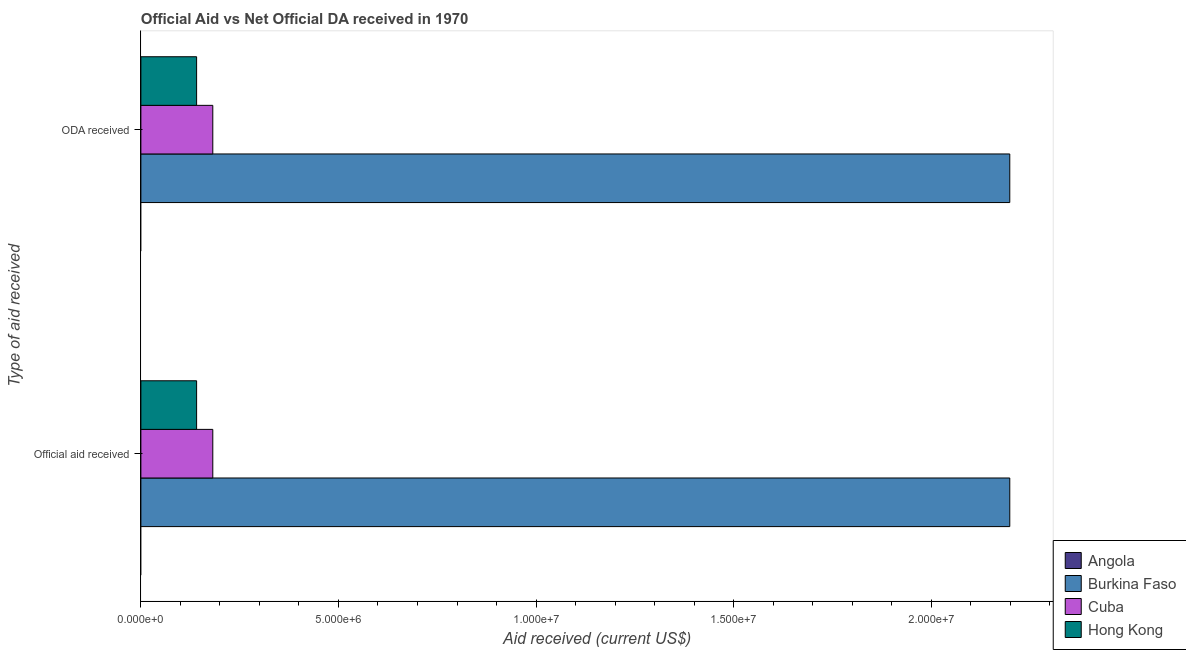How many groups of bars are there?
Ensure brevity in your answer.  2. Are the number of bars on each tick of the Y-axis equal?
Your answer should be very brief. Yes. How many bars are there on the 2nd tick from the bottom?
Make the answer very short. 3. What is the label of the 1st group of bars from the top?
Offer a very short reply. ODA received. What is the official aid received in Angola?
Your answer should be very brief. 0. Across all countries, what is the maximum oda received?
Offer a terse response. 2.20e+07. In which country was the official aid received maximum?
Ensure brevity in your answer.  Burkina Faso. What is the total oda received in the graph?
Your answer should be very brief. 2.52e+07. What is the difference between the oda received in Cuba and that in Burkina Faso?
Offer a very short reply. -2.02e+07. What is the difference between the oda received in Burkina Faso and the official aid received in Cuba?
Keep it short and to the point. 2.02e+07. What is the average official aid received per country?
Make the answer very short. 6.30e+06. What is the ratio of the oda received in Cuba to that in Burkina Faso?
Your answer should be very brief. 0.08. Is the official aid received in Burkina Faso less than that in Hong Kong?
Your response must be concise. No. In how many countries, is the oda received greater than the average oda received taken over all countries?
Make the answer very short. 1. How many bars are there?
Your answer should be compact. 6. How many countries are there in the graph?
Make the answer very short. 4. Are the values on the major ticks of X-axis written in scientific E-notation?
Make the answer very short. Yes. Does the graph contain any zero values?
Offer a very short reply. Yes. How are the legend labels stacked?
Offer a terse response. Vertical. What is the title of the graph?
Provide a succinct answer. Official Aid vs Net Official DA received in 1970 . Does "Korea (Democratic)" appear as one of the legend labels in the graph?
Keep it short and to the point. No. What is the label or title of the X-axis?
Make the answer very short. Aid received (current US$). What is the label or title of the Y-axis?
Provide a succinct answer. Type of aid received. What is the Aid received (current US$) of Angola in Official aid received?
Your answer should be very brief. 0. What is the Aid received (current US$) of Burkina Faso in Official aid received?
Ensure brevity in your answer.  2.20e+07. What is the Aid received (current US$) in Cuba in Official aid received?
Provide a short and direct response. 1.82e+06. What is the Aid received (current US$) of Hong Kong in Official aid received?
Offer a terse response. 1.41e+06. What is the Aid received (current US$) of Burkina Faso in ODA received?
Keep it short and to the point. 2.20e+07. What is the Aid received (current US$) of Cuba in ODA received?
Offer a very short reply. 1.82e+06. What is the Aid received (current US$) of Hong Kong in ODA received?
Offer a very short reply. 1.41e+06. Across all Type of aid received, what is the maximum Aid received (current US$) in Burkina Faso?
Give a very brief answer. 2.20e+07. Across all Type of aid received, what is the maximum Aid received (current US$) of Cuba?
Offer a very short reply. 1.82e+06. Across all Type of aid received, what is the maximum Aid received (current US$) of Hong Kong?
Offer a terse response. 1.41e+06. Across all Type of aid received, what is the minimum Aid received (current US$) of Burkina Faso?
Your response must be concise. 2.20e+07. Across all Type of aid received, what is the minimum Aid received (current US$) of Cuba?
Your response must be concise. 1.82e+06. Across all Type of aid received, what is the minimum Aid received (current US$) of Hong Kong?
Ensure brevity in your answer.  1.41e+06. What is the total Aid received (current US$) in Angola in the graph?
Ensure brevity in your answer.  0. What is the total Aid received (current US$) of Burkina Faso in the graph?
Give a very brief answer. 4.40e+07. What is the total Aid received (current US$) in Cuba in the graph?
Provide a short and direct response. 3.64e+06. What is the total Aid received (current US$) of Hong Kong in the graph?
Provide a succinct answer. 2.82e+06. What is the difference between the Aid received (current US$) of Cuba in Official aid received and that in ODA received?
Your response must be concise. 0. What is the difference between the Aid received (current US$) of Hong Kong in Official aid received and that in ODA received?
Keep it short and to the point. 0. What is the difference between the Aid received (current US$) of Burkina Faso in Official aid received and the Aid received (current US$) of Cuba in ODA received?
Your response must be concise. 2.02e+07. What is the difference between the Aid received (current US$) in Burkina Faso in Official aid received and the Aid received (current US$) in Hong Kong in ODA received?
Provide a succinct answer. 2.06e+07. What is the average Aid received (current US$) in Burkina Faso per Type of aid received?
Give a very brief answer. 2.20e+07. What is the average Aid received (current US$) in Cuba per Type of aid received?
Your answer should be compact. 1.82e+06. What is the average Aid received (current US$) in Hong Kong per Type of aid received?
Offer a very short reply. 1.41e+06. What is the difference between the Aid received (current US$) in Burkina Faso and Aid received (current US$) in Cuba in Official aid received?
Provide a short and direct response. 2.02e+07. What is the difference between the Aid received (current US$) in Burkina Faso and Aid received (current US$) in Hong Kong in Official aid received?
Give a very brief answer. 2.06e+07. What is the difference between the Aid received (current US$) in Burkina Faso and Aid received (current US$) in Cuba in ODA received?
Offer a terse response. 2.02e+07. What is the difference between the Aid received (current US$) in Burkina Faso and Aid received (current US$) in Hong Kong in ODA received?
Provide a succinct answer. 2.06e+07. What is the difference between the Aid received (current US$) in Cuba and Aid received (current US$) in Hong Kong in ODA received?
Provide a succinct answer. 4.10e+05. What is the ratio of the Aid received (current US$) of Cuba in Official aid received to that in ODA received?
Provide a short and direct response. 1. What is the difference between the highest and the lowest Aid received (current US$) in Cuba?
Offer a terse response. 0. 